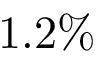<formula> <loc_0><loc_0><loc_500><loc_500>1 . 2 \%</formula> 